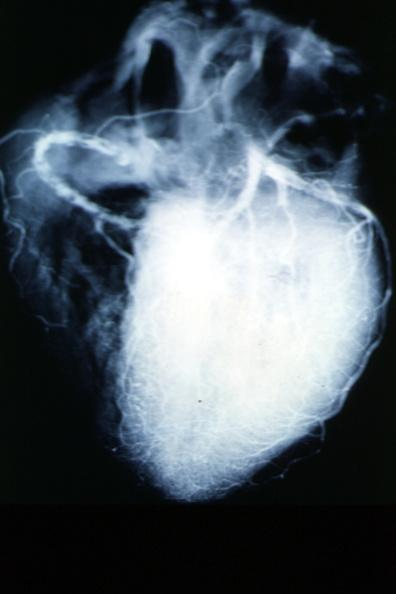s angiogram present?
Answer the question using a single word or phrase. Yes 